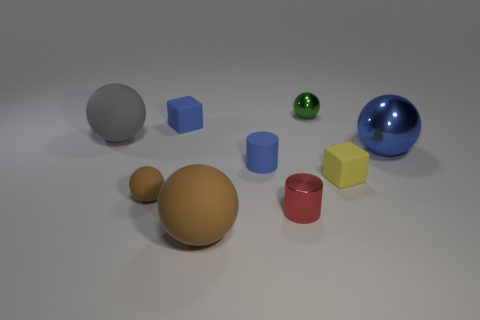Are there any other things that have the same shape as the big blue thing?
Provide a short and direct response. Yes. Are there any large rubber spheres?
Provide a succinct answer. Yes. Is the large ball in front of the blue metallic thing made of the same material as the big thing to the right of the tiny green ball?
Offer a very short reply. No. How big is the sphere in front of the brown matte object behind the small shiny cylinder that is left of the small metallic sphere?
Make the answer very short. Large. How many red cylinders are made of the same material as the blue cylinder?
Keep it short and to the point. 0. Are there fewer balls than large red objects?
Your response must be concise. No. There is another thing that is the same shape as the small red object; what is its size?
Make the answer very short. Small. Does the large ball behind the blue metallic thing have the same material as the green object?
Your response must be concise. No. Do the large gray thing and the blue shiny object have the same shape?
Keep it short and to the point. Yes. What number of things are large rubber balls that are behind the red metallic object or gray cylinders?
Provide a succinct answer. 1. 